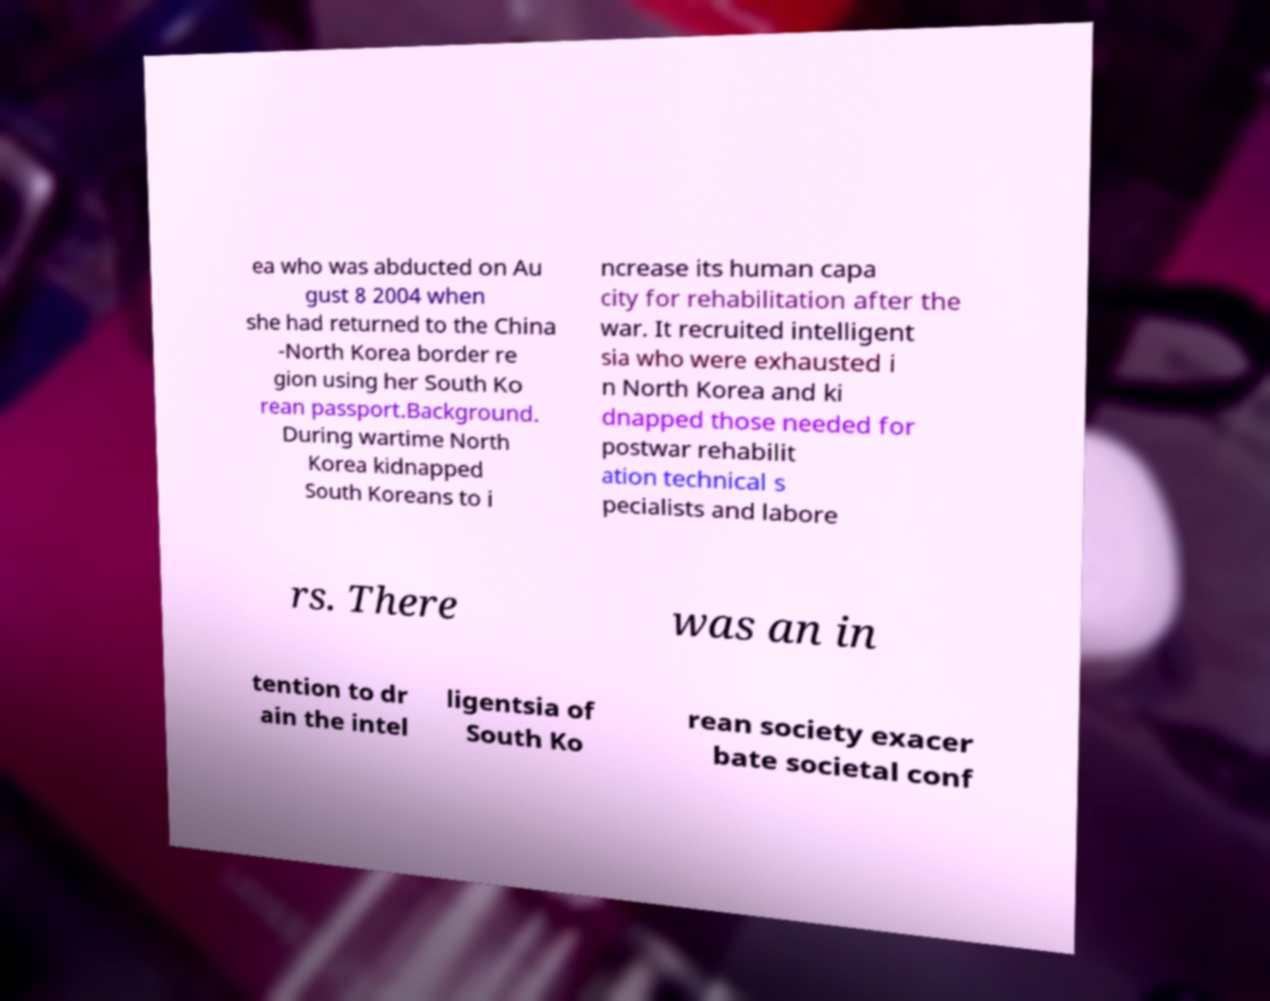Please identify and transcribe the text found in this image. ea who was abducted on Au gust 8 2004 when she had returned to the China -North Korea border re gion using her South Ko rean passport.Background. During wartime North Korea kidnapped South Koreans to i ncrease its human capa city for rehabilitation after the war. It recruited intelligent sia who were exhausted i n North Korea and ki dnapped those needed for postwar rehabilit ation technical s pecialists and labore rs. There was an in tention to dr ain the intel ligentsia of South Ko rean society exacer bate societal conf 